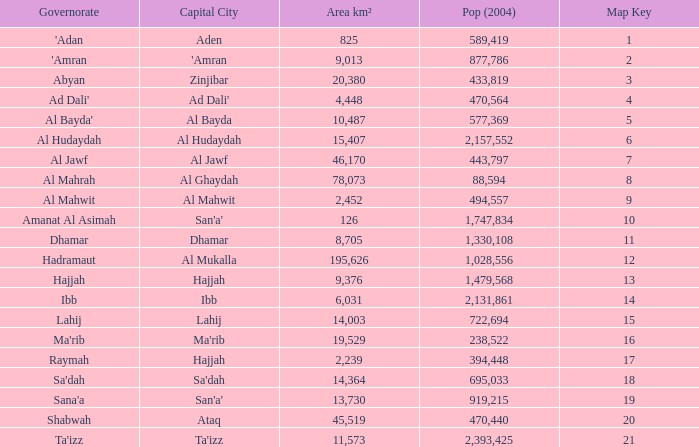Determine the aggregate population of al mahrah governorate in 2004 with an area less than 78,073 km². None. 